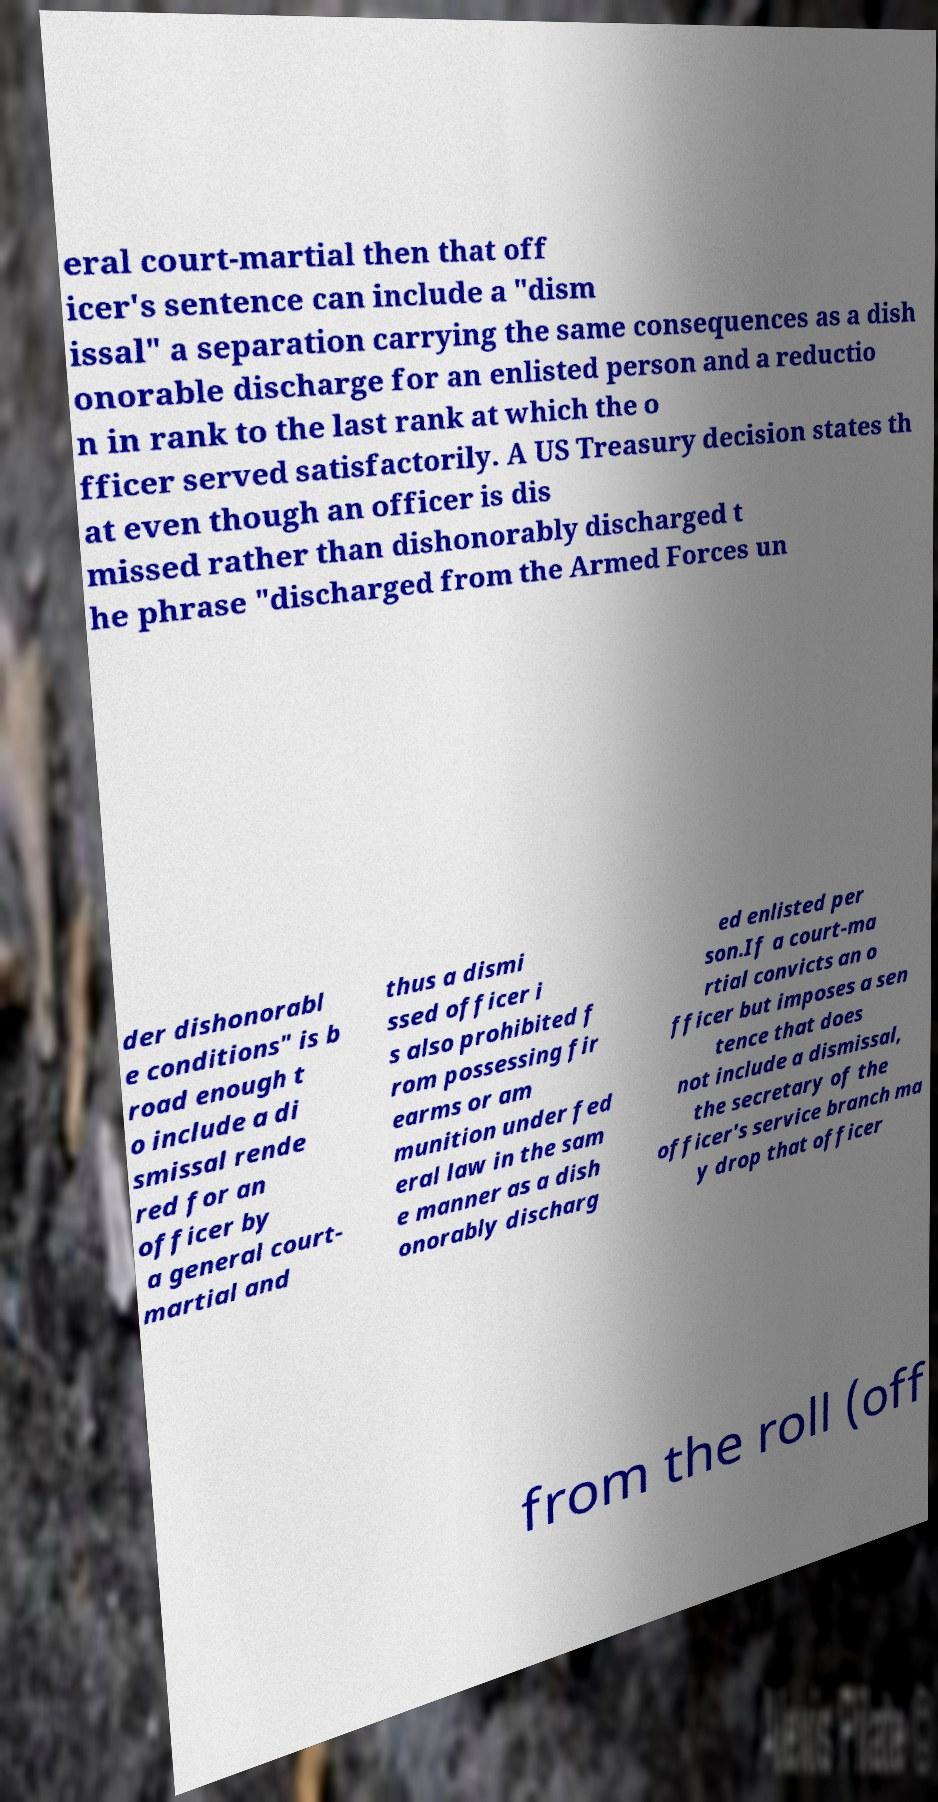I need the written content from this picture converted into text. Can you do that? eral court-martial then that off icer's sentence can include a "dism issal" a separation carrying the same consequences as a dish onorable discharge for an enlisted person and a reductio n in rank to the last rank at which the o fficer served satisfactorily. A US Treasury decision states th at even though an officer is dis missed rather than dishonorably discharged t he phrase "discharged from the Armed Forces un der dishonorabl e conditions" is b road enough t o include a di smissal rende red for an officer by a general court- martial and thus a dismi ssed officer i s also prohibited f rom possessing fir earms or am munition under fed eral law in the sam e manner as a dish onorably discharg ed enlisted per son.If a court-ma rtial convicts an o fficer but imposes a sen tence that does not include a dismissal, the secretary of the officer's service branch ma y drop that officer from the roll (off 